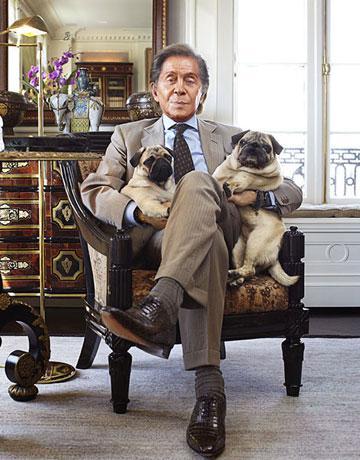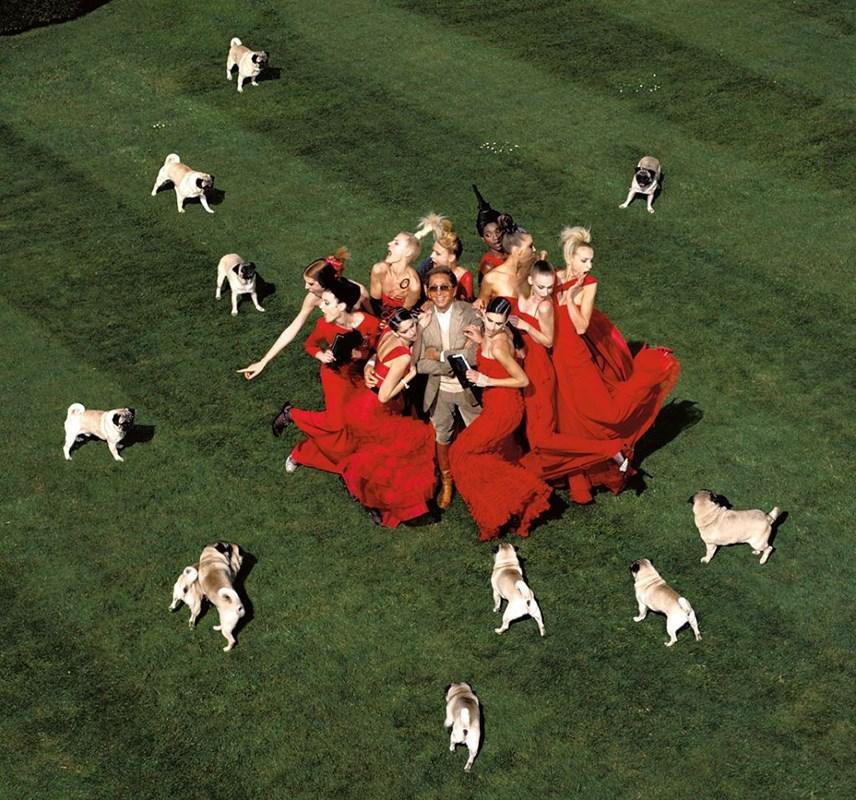The first image is the image on the left, the second image is the image on the right. For the images shown, is this caption "One of the images shows only one dog and one man." true? Answer yes or no. No. The first image is the image on the left, the second image is the image on the right. Considering the images on both sides, is "The right image contains no more than one dog." valid? Answer yes or no. No. 